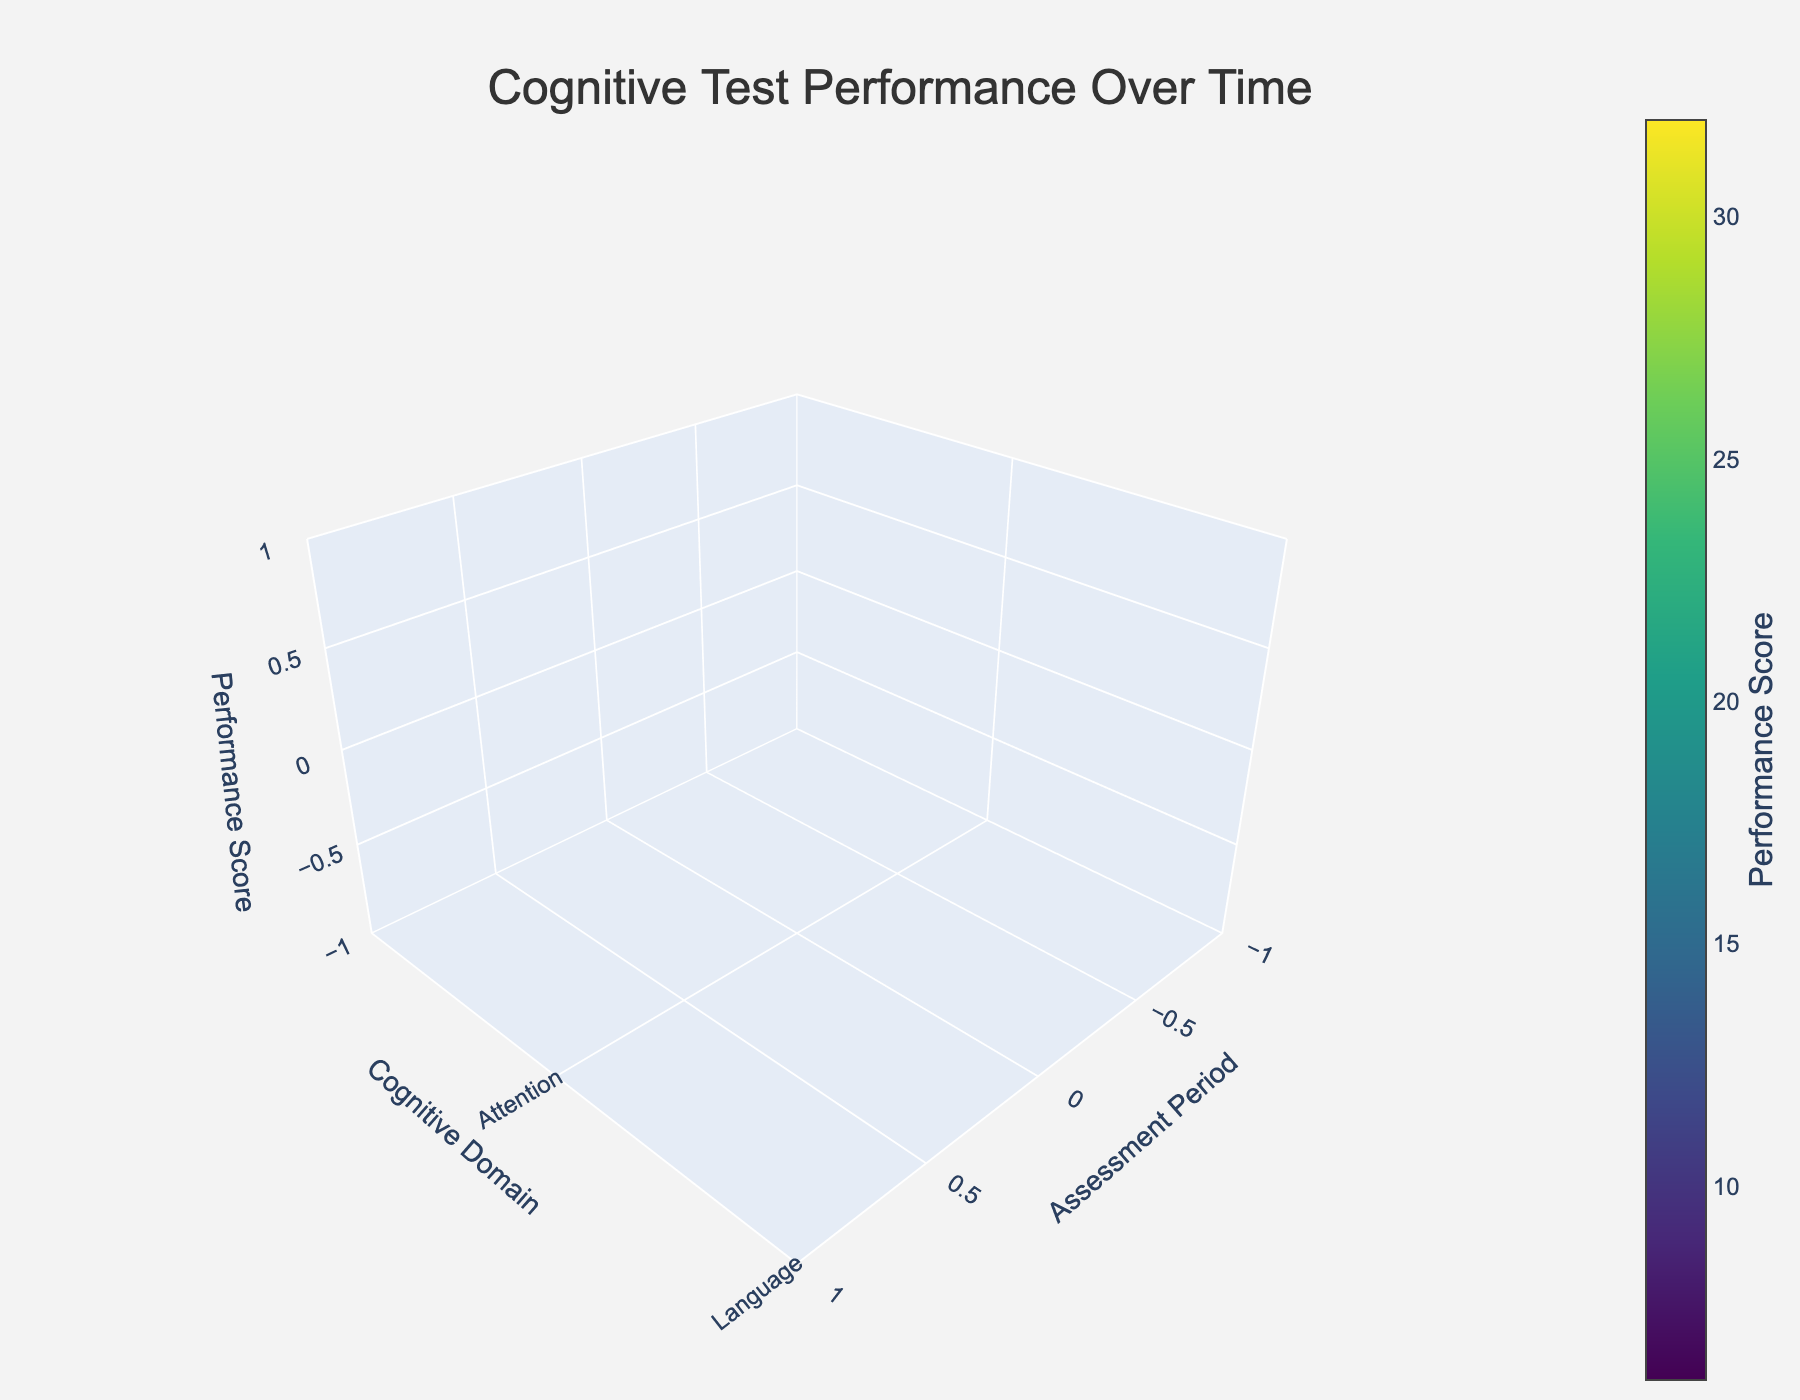How many cognitive domains are evaluated in the plot? The plot evaluates the performance scores across three cognitive domains. This is evident from the three distinct 'y' axis labels: Memory, Attention, and Language.
Answer: 3 What is the title of the plot? The title of the plot is provided as 'Cognitive Test Performance Over Time', which can be seen at the top of the figure.
Answer: Cognitive Test Performance Over Time Which domain has the highest performance score in the first assessment period? In the first assessment period, Language has the highest performance score. This can be visually identified as it corresponds to the highest 'z' axis value for the first 'x' axis value (Assessment Period 1).
Answer: Language What trend is visible in the memory performance scores over the assessment periods? Memory performance scores show a decreasing trend over time. This is observed as the 'z' axis values for Memory decrease consistently from the first to the last assessment period.
Answer: Decreasing trend Compare the performance score in Language for the first and last assessment periods. In the first assessment period, the Language score is 32. In the last assessment period, the score has decreased to 22. This comparison shows a decrease of 10 points.
Answer: Decreased by 10 What is the general relationship between assessment periods and performance scores for all cognitive domains? Generally, as assessment periods increase, performance scores decrease across all cognitive domains. This downward trend is visually evident for Memory, Attention, and Language from the first to the last assessment period.
Answer: Decreasing relationship Which cognitive domain shows the smallest decline in performance over time? Among the cognitive domains, Language shows the smallest decline over time, from a performance score of 32 in the first assessment period to 22 in the last, a reduction of 10 points. Memory and Attention have larger drops.
Answer: Language What's the average performance score across all domains in the second assessment period? In the second assessment period, the scores are 12 (Memory), 25 (Attention), and 30 (Language). The average score is calculated as (12 + 25 + 30) / 3 = 22.33
Answer: 22.33 